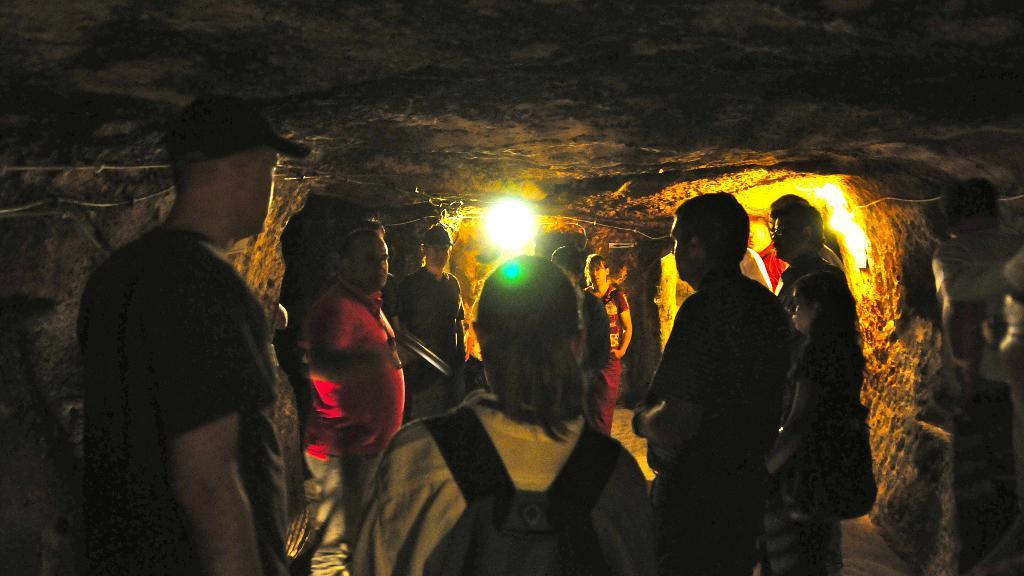In one or two sentences, can you explain what this image depicts? The picture might be taken inside a cave. In the picture we can see group of people. At the top it is rock. In the background we can see light. 